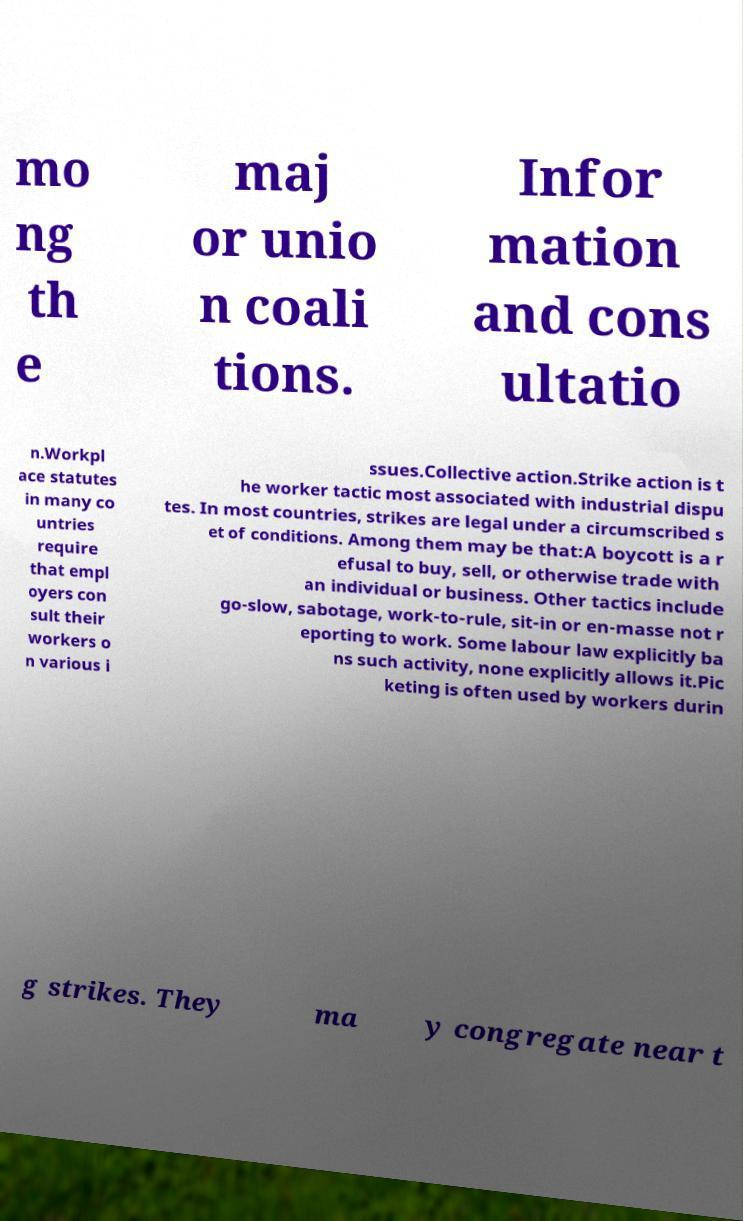What messages or text are displayed in this image? I need them in a readable, typed format. mo ng th e maj or unio n coali tions. Infor mation and cons ultatio n.Workpl ace statutes in many co untries require that empl oyers con sult their workers o n various i ssues.Collective action.Strike action is t he worker tactic most associated with industrial dispu tes. In most countries, strikes are legal under a circumscribed s et of conditions. Among them may be that:A boycott is a r efusal to buy, sell, or otherwise trade with an individual or business. Other tactics include go-slow, sabotage, work-to-rule, sit-in or en-masse not r eporting to work. Some labour law explicitly ba ns such activity, none explicitly allows it.Pic keting is often used by workers durin g strikes. They ma y congregate near t 